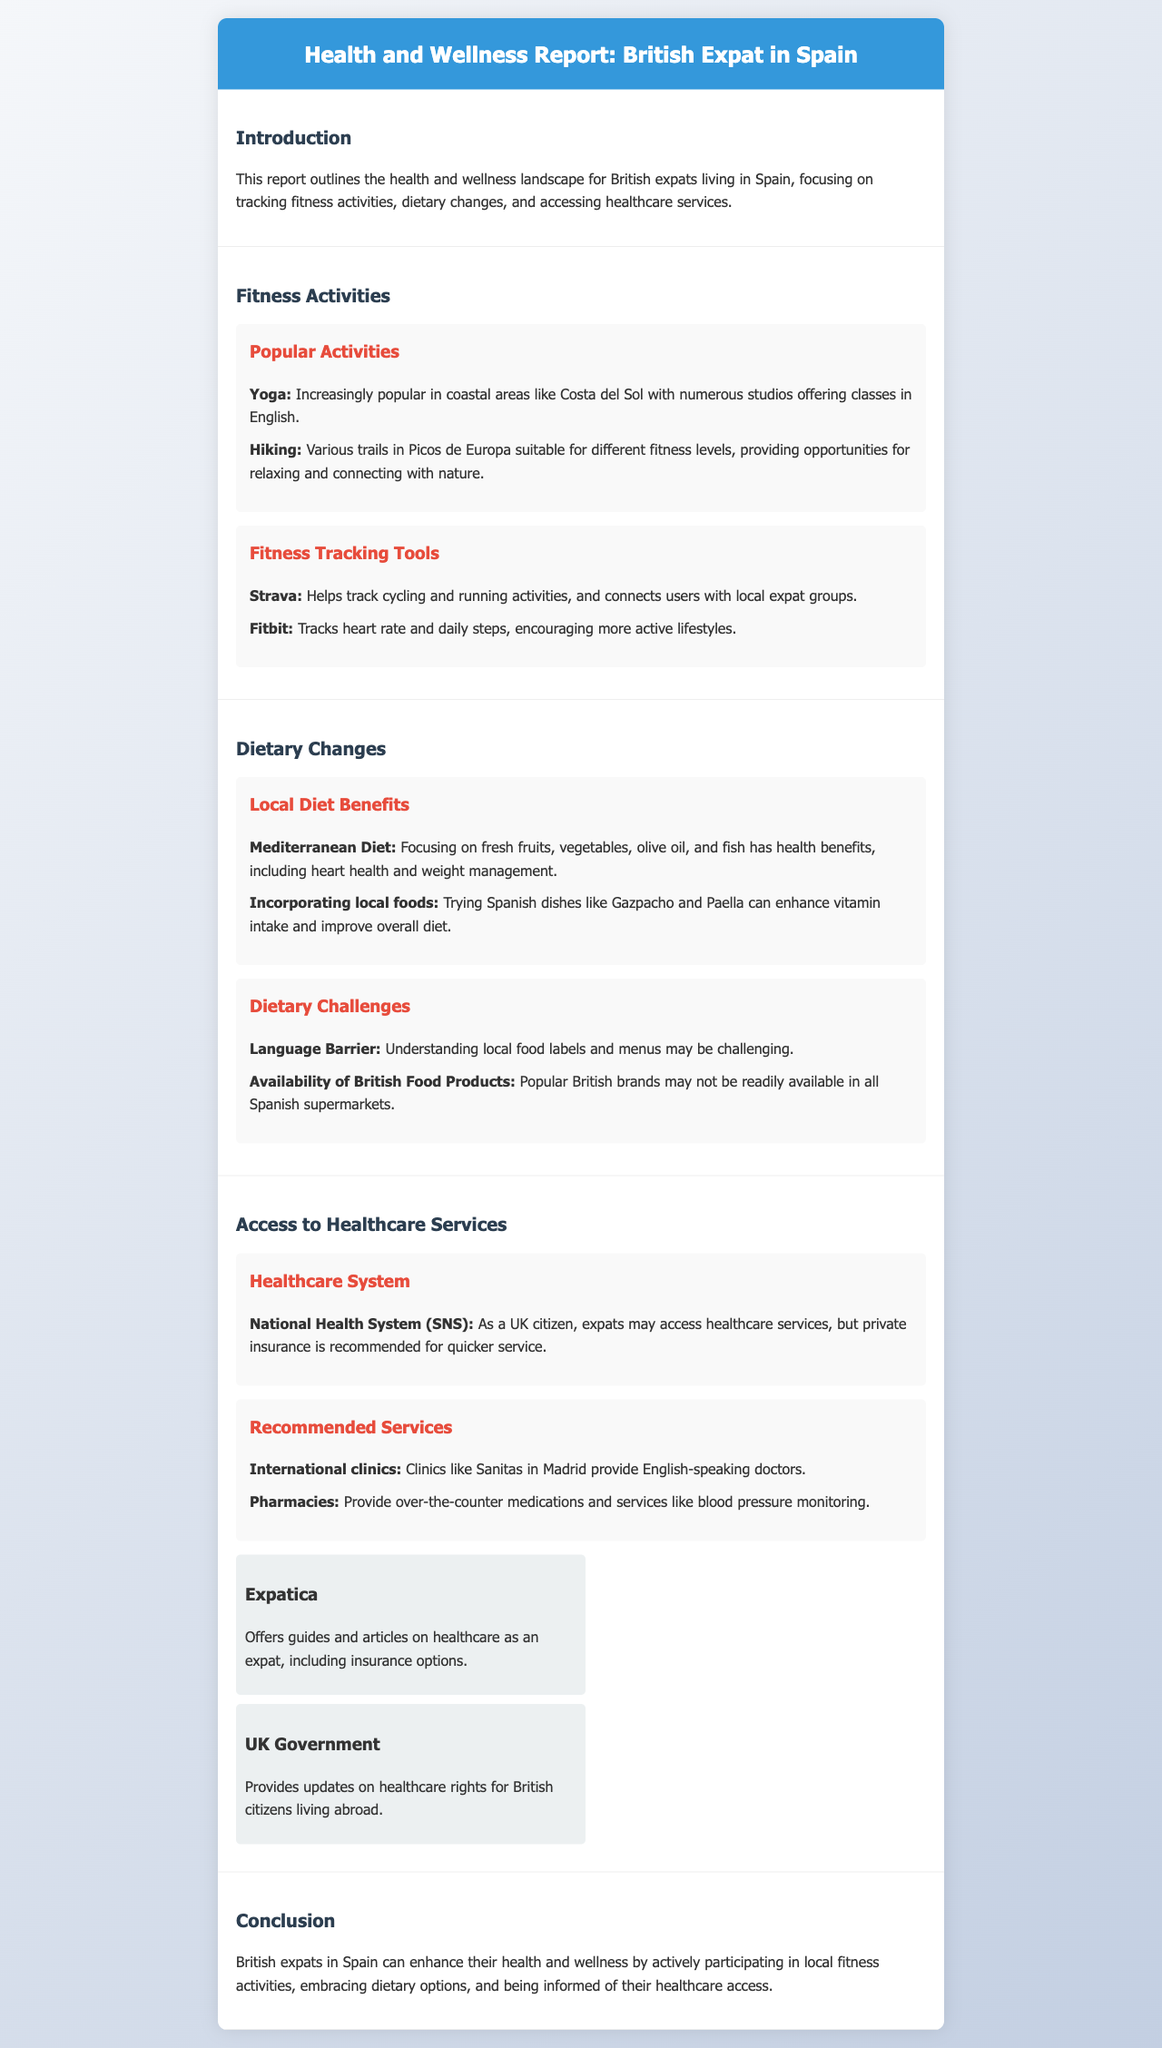what are popular fitness activities for British expats in Spain? The document lists popular activities such as Yoga and Hiking.
Answer: Yoga, Hiking what is one tool recommended for fitness tracking? The document mentions Strava as a fitness tracking tool.
Answer: Strava what diet is beneficial for health according to the report? The Mediterranean Diet is highlighted for its health benefits in the document.
Answer: Mediterranean Diet what dietary challenge do British expats face in Spain? The document states that the language barrier is a challenge when understanding food labels and menus.
Answer: Language Barrier which healthcare system can British expats access in Spain? The report identifies the National Health System (SNS) as accessible to UK citizens.
Answer: National Health System (SNS) how many recommendations are listed for accessing healthcare services? The document provides two recommended services for accessing healthcare.
Answer: Two what does the Expatica resource offer? Expatica offers guides and articles on healthcare as an expat.
Answer: Guides and articles on healthcare which common Spanish dish is mentioned as beneficial for diet? The document mentions Gazpacho as a Spanish dish that can enhance vitamin intake.
Answer: Gazpacho what type of clinics are recommended for English-speaking doctors? The report recommends international clinics like Sanitas for English-speaking doctors.
Answer: International clinics 